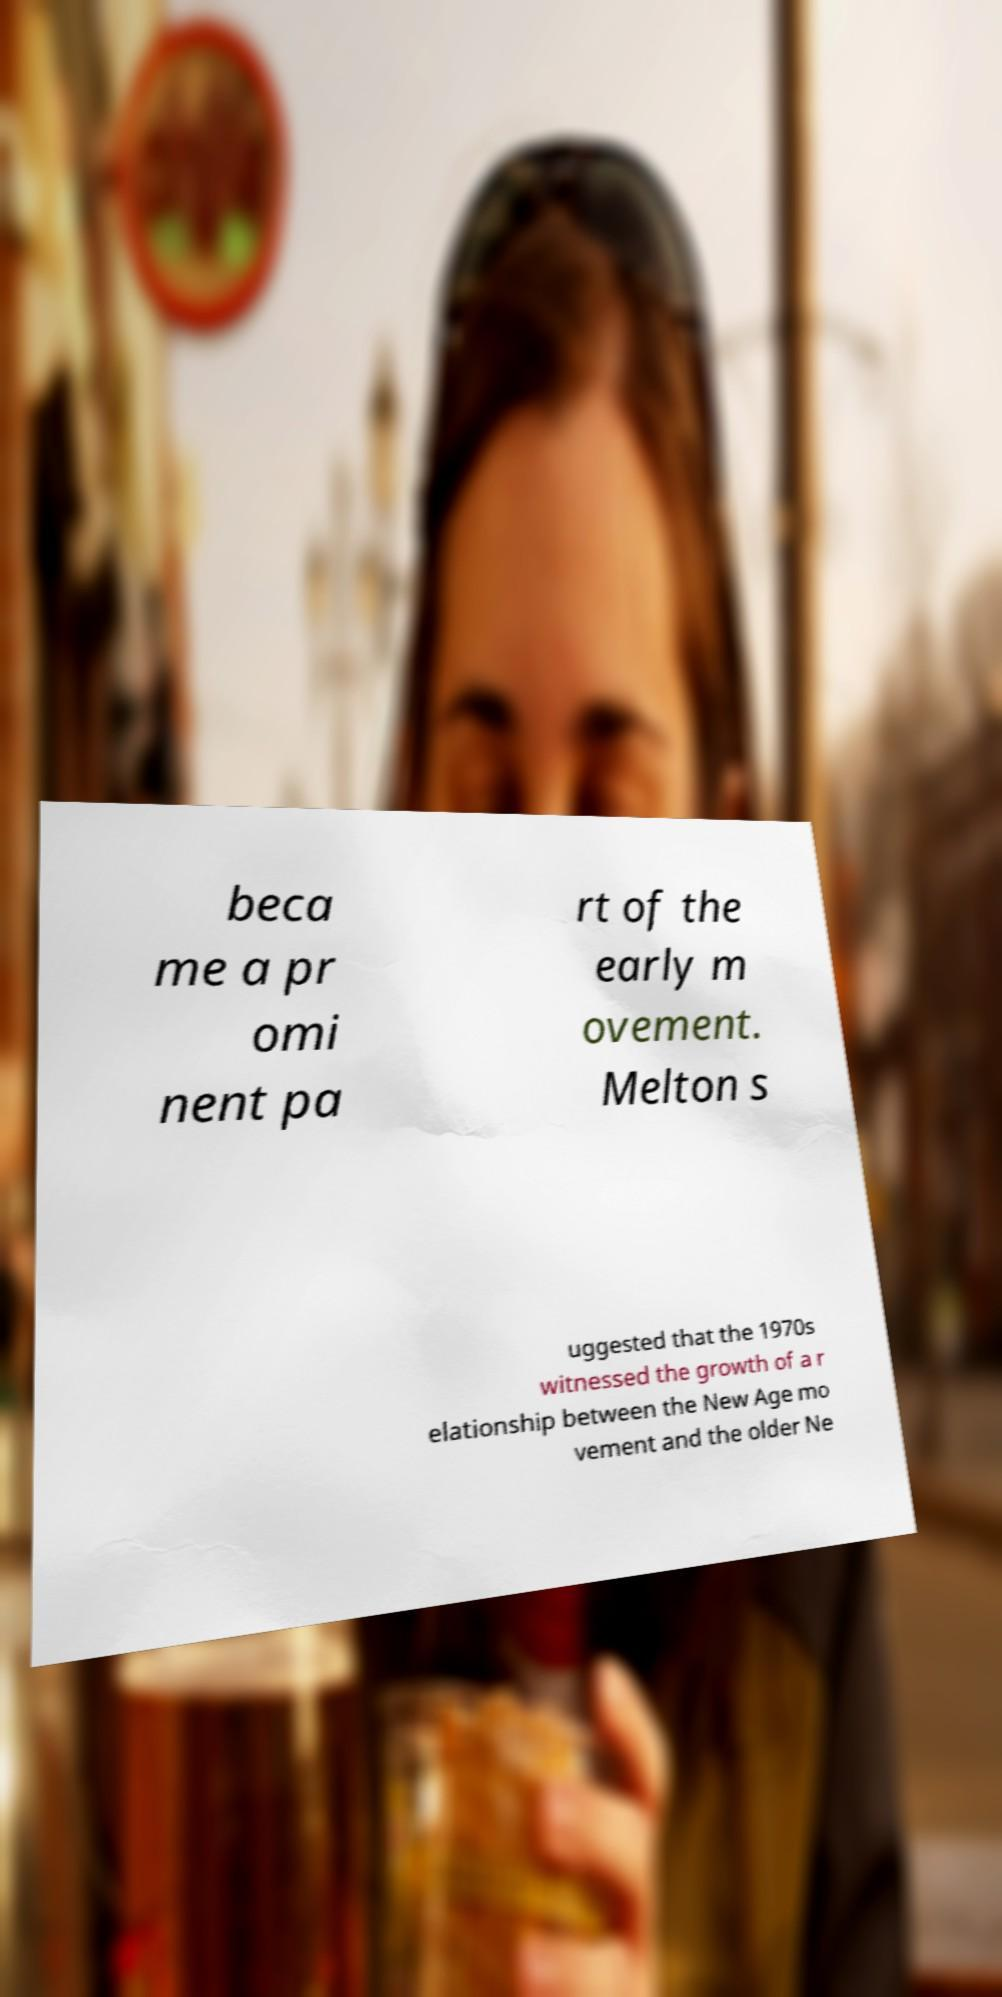Can you read and provide the text displayed in the image?This photo seems to have some interesting text. Can you extract and type it out for me? beca me a pr omi nent pa rt of the early m ovement. Melton s uggested that the 1970s witnessed the growth of a r elationship between the New Age mo vement and the older Ne 